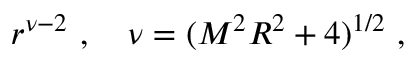<formula> <loc_0><loc_0><loc_500><loc_500>r ^ { \nu - 2 } \ , \quad \nu = ( M ^ { 2 } R ^ { 2 } + 4 ) ^ { 1 / 2 } \ ,</formula> 